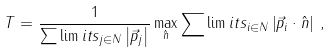<formula> <loc_0><loc_0><loc_500><loc_500>T = \frac { 1 } { \sum \lim i t s _ { j \in N } \left | \vec { p } _ { j } \right | } \max _ { \hat { n } } \sum \lim i t s _ { i \in N } \left | \vec { p } _ { i } \cdot \hat { n } \right | \, ,</formula> 